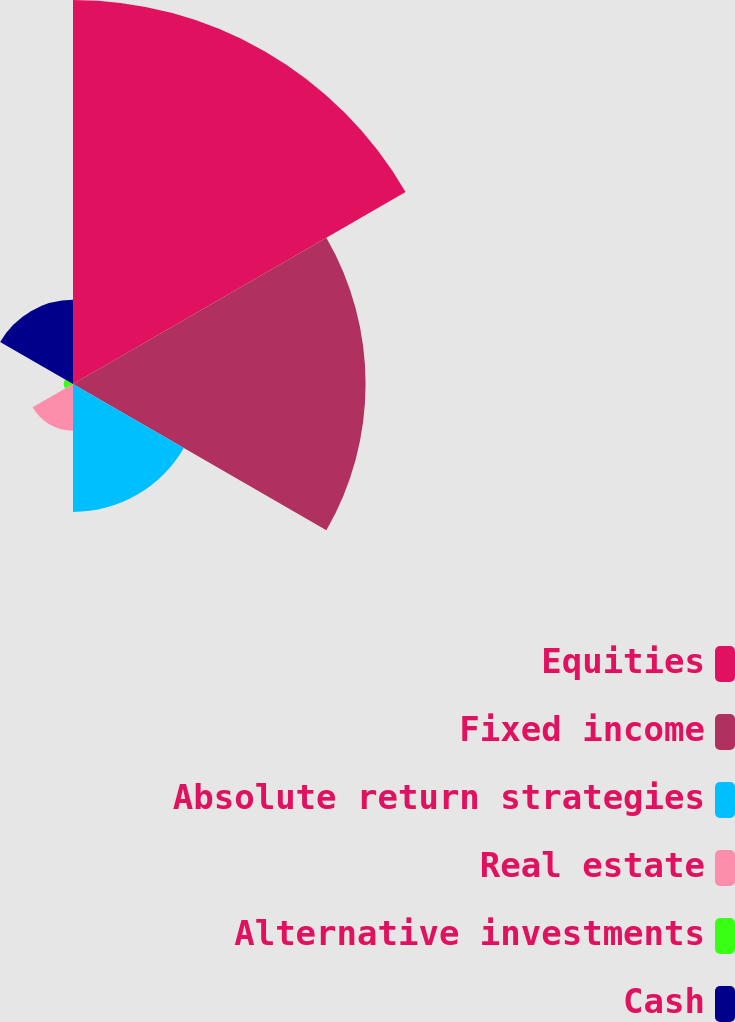<chart> <loc_0><loc_0><loc_500><loc_500><pie_chart><fcel>Equities<fcel>Fixed income<fcel>Absolute return strategies<fcel>Real estate<fcel>Alternative investments<fcel>Cash<nl><fcel>40.66%<fcel>30.98%<fcel>13.55%<fcel>4.94%<fcel>0.97%<fcel>8.91%<nl></chart> 